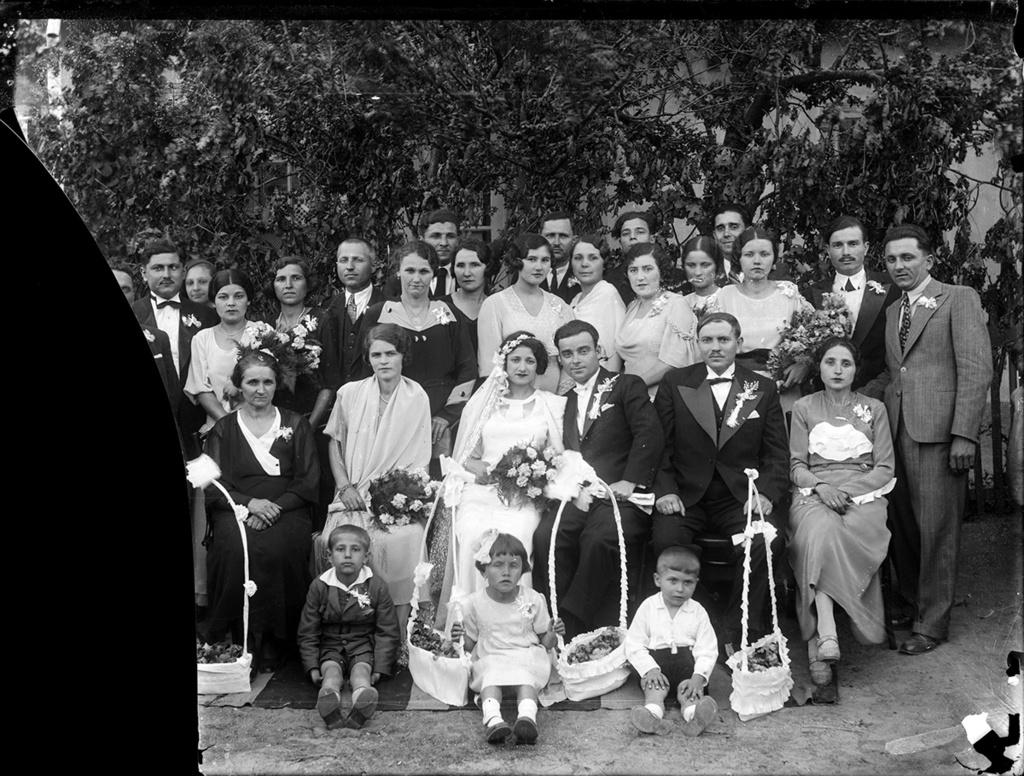What is the color scheme of the image? The image is black and white. What is happening in the image involving a group of people? The group of people are taking a photo with the wedding couple. What can be seen in the background of the image? There are a lot of trees in the background of the image. What type of pin is the wedding couple wearing in the image? There is no pin visible on the wedding couple in the image. What color is the sweater worn by the person standing next to the wedding couple? The image is black and white, so it is not possible to determine the color of any clothing items. 